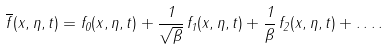<formula> <loc_0><loc_0><loc_500><loc_500>\overline { f } ( x , \eta , t ) = f _ { 0 } ( x , \eta , t ) + \frac { 1 } { \sqrt { \beta } } \, f _ { 1 } ( x , \eta , t ) + \frac { 1 } { \beta } \, f _ { 2 } ( x , \eta , t ) + \dots .</formula> 